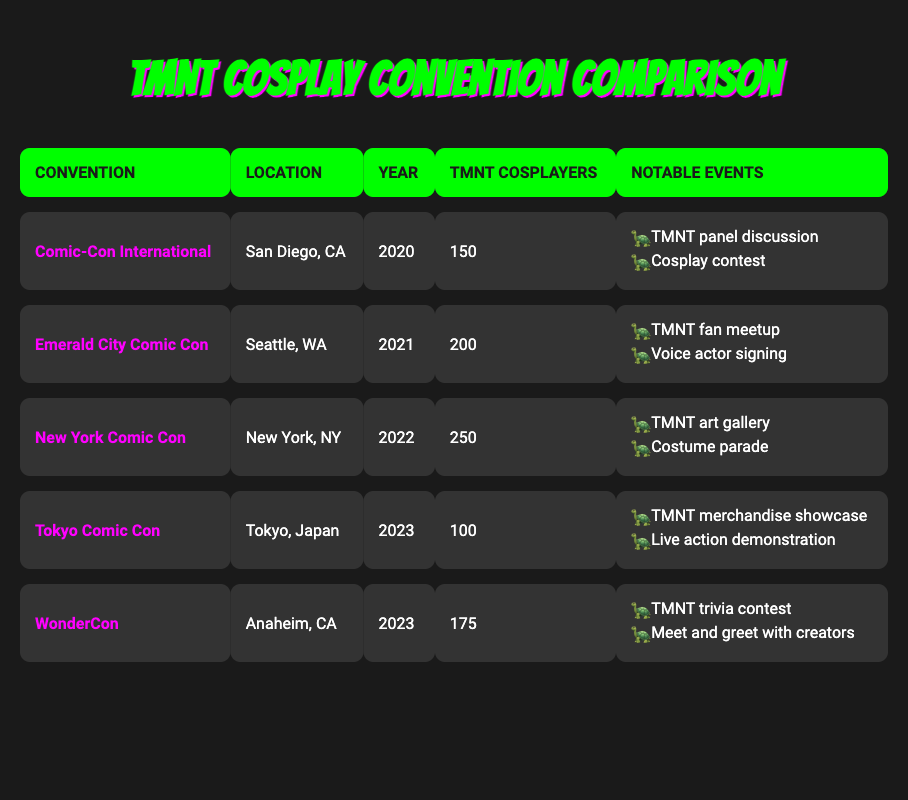What is the convention with the highest number of TMNT cosplayers? Looking at the table, we identify the number of TMNT cosplayers for each convention. The maximum is 250, which corresponds to New York Comic Con in 2022.
Answer: New York Comic Con How many TMNT cosplayers attended Tokyo Comic Con in 2023? The table shows the number of TMNT cosplayers for Tokyo Comic Con as 100.
Answer: 100 What is the total number of TMNT cosplayers from all conventions listed in 2023? We see two conventions in 2023: Tokyo Comic Con with 100 cosplayers and WonderCon with 175. Adding these gives 100 + 175 = 275.
Answer: 275 Did Emerald City Comic Con have more than 200 TMNT cosplayers? The number of TMNT cosplayers at Emerald City Comic Con is 200. Since it is not greater than 200, the answer is no.
Answer: No Which convention had the least number of TMNT cosplayers and what was the number? A comparison of all the conventions shows that Tokyo Comic Con in 2023 had the lowest attendance with 100 TMNT cosplayers.
Answer: Tokyo Comic Con, 100 What was the average number of TMNT cosplayers across all conventions? We can calculate the total number of cosplayers across all conventions: 150 + 200 + 250 + 100 + 175 = 875. There are 5 conventions, so the average is 875 / 5 = 175.
Answer: 175 Did New York Comic Con have notable events related to TMNT art? Yes, the table lists an art gallery as one of the notable events for New York Comic Con in 2022, indicating that it did feature TMNT art.
Answer: Yes Which convention had both a trivia contest and a meet and greet with creators? Only WonderCon listed in 2023 had a trivia contest and a meet and greet with creators as notable events.
Answer: WonderCon 